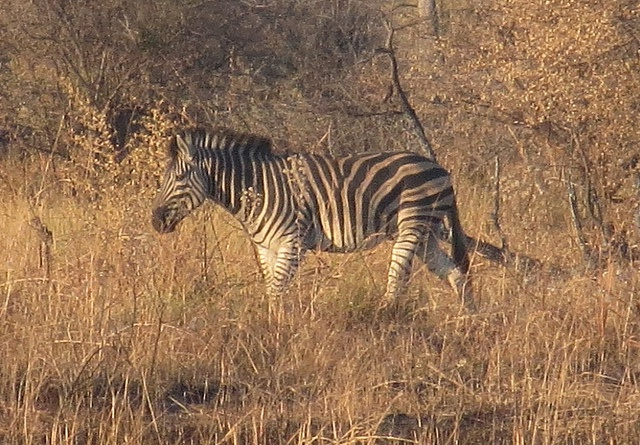Describe the objects in this image and their specific colors. I can see a zebra in gray, maroon, and black tones in this image. 